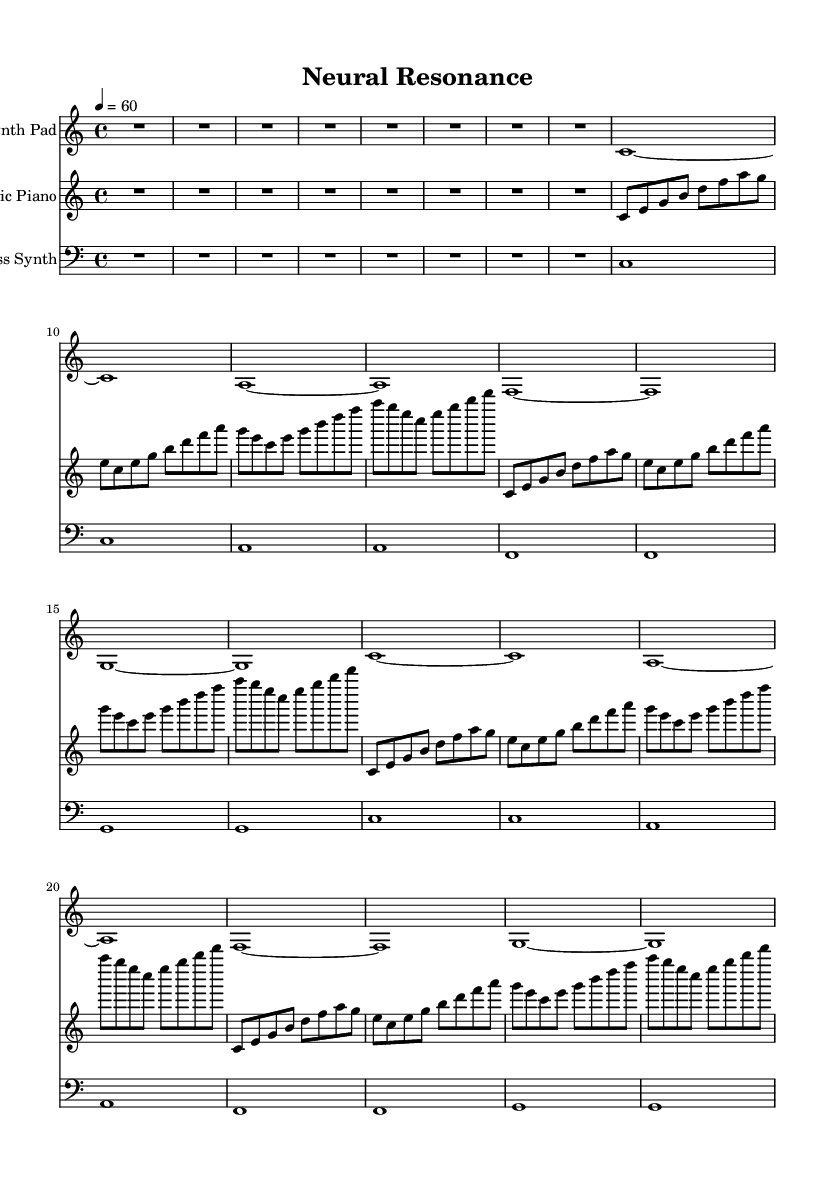What is the key signature of this music? The key signature is C major, indicated by the absence of any sharps or flats in the sheet music. The term "C major" can be inferred from the context of the music generated and is part of the global variables defined.
Answer: C major What is the time signature of this music? The time signature is 4/4, which is called common time. This is indicated by the "4/4" notation in the global variables of the code under the global context.
Answer: 4/4 What is the tempo of this piece? The tempo is set at 60 beats per minute. This is specifically mentioned as "4 = 60" in the global configuration, indicating the speed of the music.
Answer: 60 How many bars are in Section A? Section A contains 16 bars, as indicated by the structure defined in the synthPad, electricPiano, and bassSynth sections where each is stated to repeat certain phrases.
Answer: 16 How many instruments are used in this piece? There are three instruments used: Synth Pad, Electric Piano, and Bass Synth. Each is represented by a different staff in the score section, indicating the distinct voices for each instrument.
Answer: Three What is the first note played by the electric piano? The first note is C. This is apparent as the electric piano begins with a sequence that starts on the note C, as represented in the music sheet.
Answer: C What type of texture is primarily used in this composition? The texture is primarily homophonic, as there is clearly defined melody in the electric piano supported by harmonic backgrounds from the synthPad and bassSynth. The main melody lines dominate, with chords supporting it.
Answer: Homophonic 